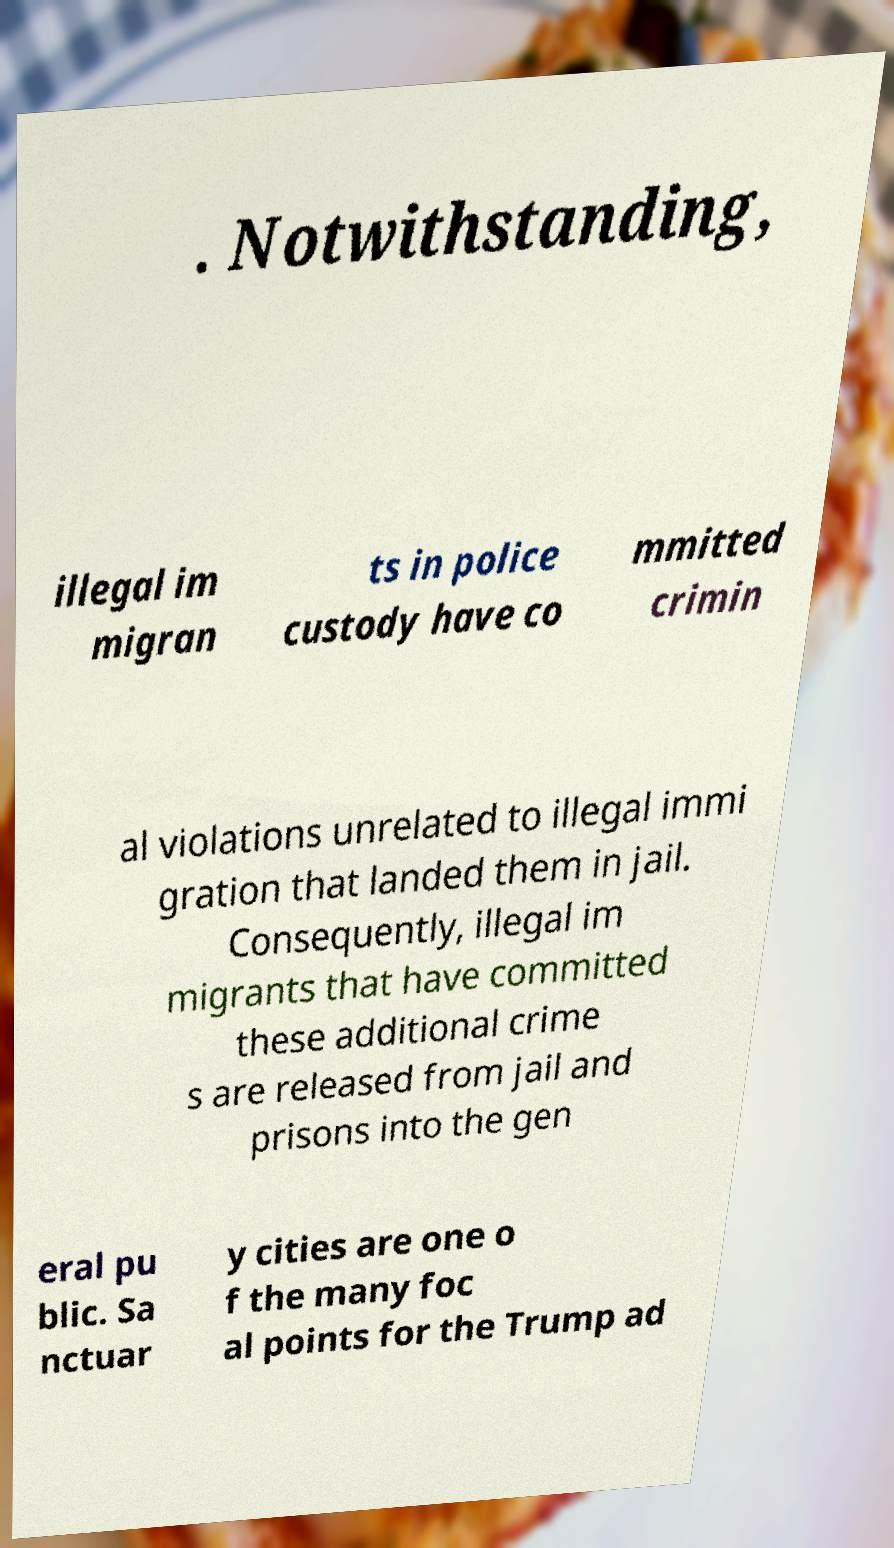Can you read and provide the text displayed in the image?This photo seems to have some interesting text. Can you extract and type it out for me? . Notwithstanding, illegal im migran ts in police custody have co mmitted crimin al violations unrelated to illegal immi gration that landed them in jail. Consequently, illegal im migrants that have committed these additional crime s are released from jail and prisons into the gen eral pu blic. Sa nctuar y cities are one o f the many foc al points for the Trump ad 